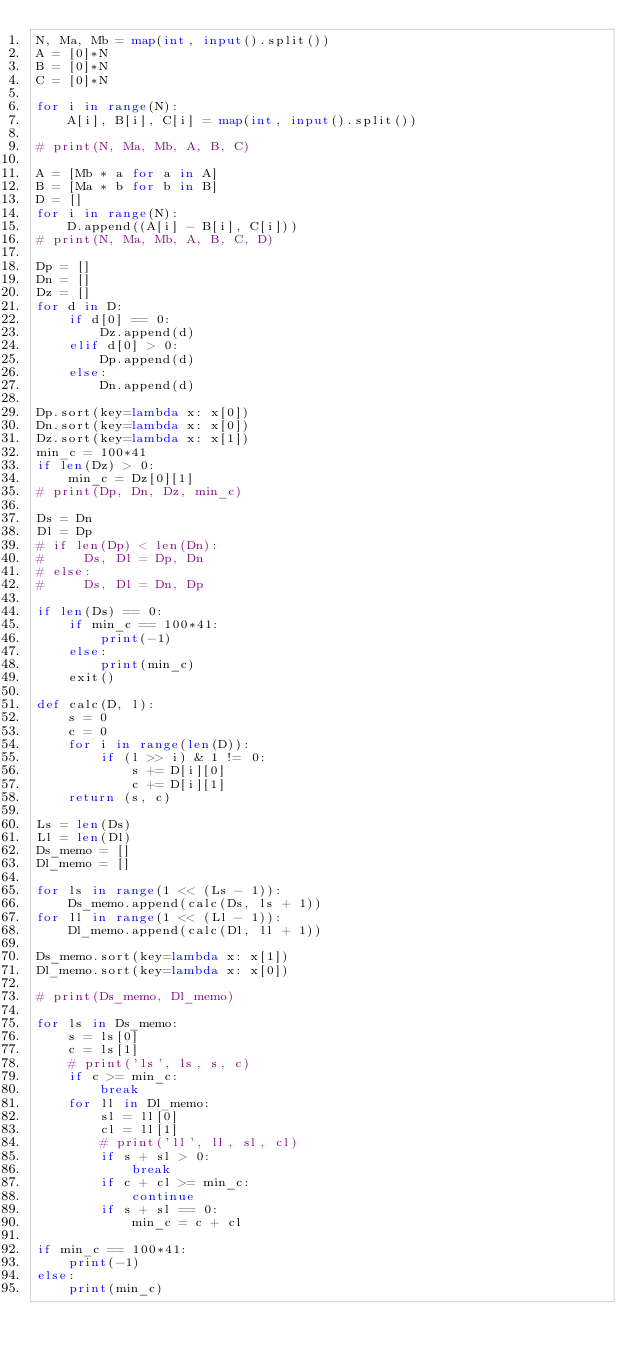<code> <loc_0><loc_0><loc_500><loc_500><_Python_>N, Ma, Mb = map(int, input().split())
A = [0]*N
B = [0]*N
C = [0]*N

for i in range(N):
    A[i], B[i], C[i] = map(int, input().split())

# print(N, Ma, Mb, A, B, C)

A = [Mb * a for a in A]
B = [Ma * b for b in B]
D = []
for i in range(N):
    D.append((A[i] - B[i], C[i]))
# print(N, Ma, Mb, A, B, C, D)

Dp = []
Dn = []
Dz = []
for d in D:
    if d[0] == 0:
        Dz.append(d)
    elif d[0] > 0:
        Dp.append(d)
    else:
        Dn.append(d)

Dp.sort(key=lambda x: x[0])
Dn.sort(key=lambda x: x[0])
Dz.sort(key=lambda x: x[1])
min_c = 100*41
if len(Dz) > 0:
    min_c = Dz[0][1]
# print(Dp, Dn, Dz, min_c)

Ds = Dn
Dl = Dp
# if len(Dp) < len(Dn):
#     Ds, Dl = Dp, Dn
# else:
#     Ds, Dl = Dn, Dp

if len(Ds) == 0:
    if min_c == 100*41:
        print(-1)
    else:
        print(min_c)
    exit()

def calc(D, l):
    s = 0
    c = 0
    for i in range(len(D)):
        if (l >> i) & 1 != 0:
            s += D[i][0]
            c += D[i][1]
    return (s, c)

Ls = len(Ds)
Ll = len(Dl)
Ds_memo = []
Dl_memo = []

for ls in range(1 << (Ls - 1)):
    Ds_memo.append(calc(Ds, ls + 1))
for ll in range(1 << (Ll - 1)):
    Dl_memo.append(calc(Dl, ll + 1))

Ds_memo.sort(key=lambda x: x[1])
Dl_memo.sort(key=lambda x: x[0])

# print(Ds_memo, Dl_memo)

for ls in Ds_memo:
    s = ls[0]
    c = ls[1]
    # print('ls', ls, s, c)
    if c >= min_c:
        break
    for ll in Dl_memo:
        sl = ll[0]
        cl = ll[1]
        # print('ll', ll, sl, cl)
        if s + sl > 0:
            break
        if c + cl >= min_c:
            continue
        if s + sl == 0:
            min_c = c + cl

if min_c == 100*41:
    print(-1)
else:
    print(min_c)
</code> 